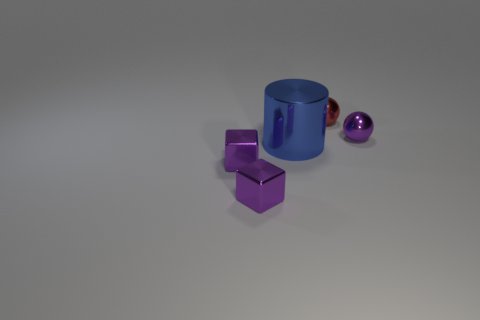How many cubes have the same size as the red metal sphere?
Give a very brief answer. 2. Is the number of tiny matte cylinders less than the number of red balls?
Your answer should be compact. Yes. There is a large blue metallic thing that is to the left of the metallic sphere in front of the red ball; what is its shape?
Ensure brevity in your answer.  Cylinder. There is a red metallic thing that is the same size as the purple metal sphere; what is its shape?
Offer a terse response. Sphere. Is there a tiny purple thing of the same shape as the blue object?
Your response must be concise. No. What is the purple ball made of?
Your answer should be compact. Metal. Are there any red balls behind the tiny purple ball?
Offer a terse response. Yes. How many spheres are behind the shiny object that is on the right side of the red metallic sphere?
Your response must be concise. 1. What material is the sphere that is the same size as the red thing?
Your answer should be compact. Metal. What number of other things are there of the same material as the large cylinder
Offer a very short reply. 4. 